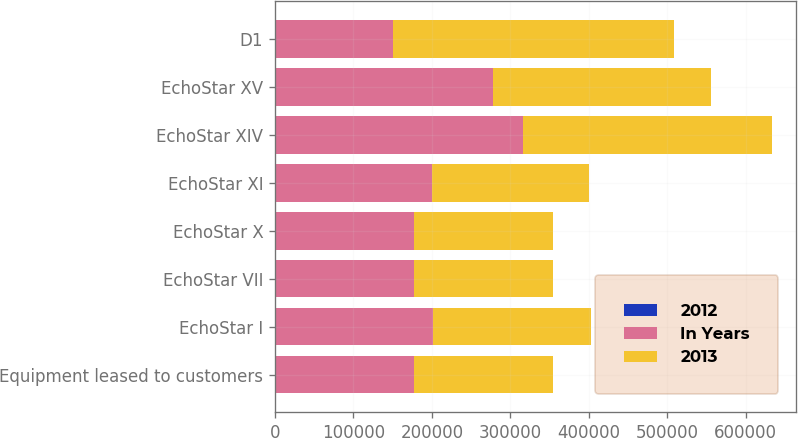<chart> <loc_0><loc_0><loc_500><loc_500><stacked_bar_chart><ecel><fcel>Equipment leased to customers<fcel>EchoStar I<fcel>EchoStar VII<fcel>EchoStar X<fcel>EchoStar XI<fcel>EchoStar XIV<fcel>EchoStar XV<fcel>D1<nl><fcel>2012<fcel>25<fcel>12<fcel>15<fcel>15<fcel>15<fcel>15<fcel>15<fcel>15<nl><fcel>In Years<fcel>177096<fcel>201607<fcel>177000<fcel>177192<fcel>200198<fcel>316541<fcel>277658<fcel>150000<nl><fcel>2013<fcel>177096<fcel>201607<fcel>177000<fcel>177192<fcel>200198<fcel>316541<fcel>277658<fcel>358141<nl></chart> 